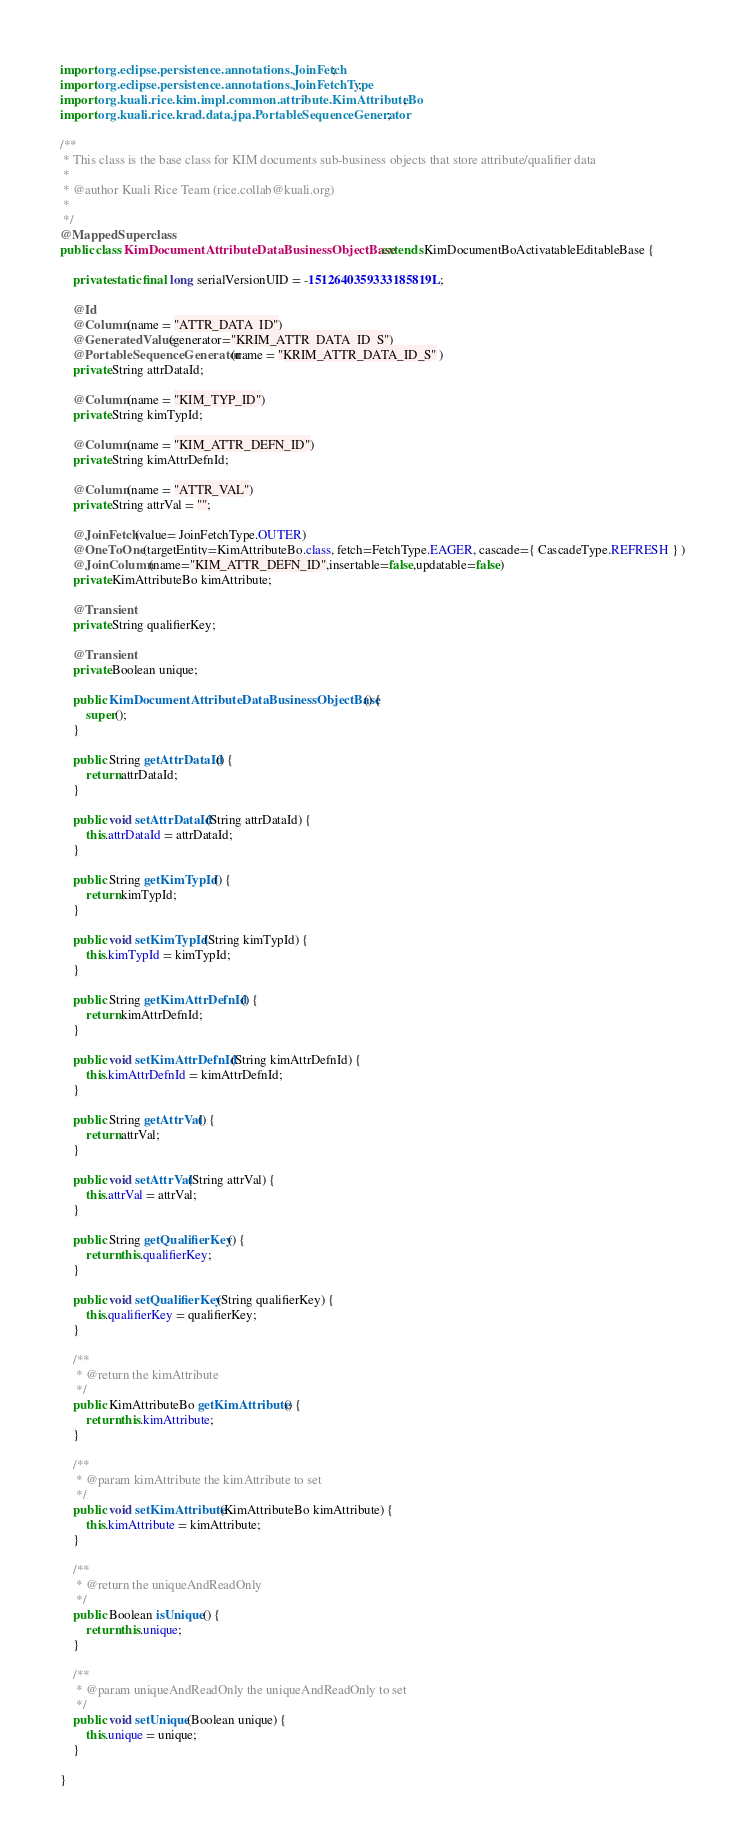<code> <loc_0><loc_0><loc_500><loc_500><_Java_>
import org.eclipse.persistence.annotations.JoinFetch;
import org.eclipse.persistence.annotations.JoinFetchType;
import org.kuali.rice.kim.impl.common.attribute.KimAttributeBo;
import org.kuali.rice.krad.data.jpa.PortableSequenceGenerator;

/**
 * This class is the base class for KIM documents sub-business objects that store attribute/qualifier data
 * 
 * @author Kuali Rice Team (rice.collab@kuali.org)
 *
 */
@MappedSuperclass
public class KimDocumentAttributeDataBusinessObjectBase extends KimDocumentBoActivatableEditableBase {

    private static final long serialVersionUID = -1512640359333185819L;

	@Id
	@Column(name = "ATTR_DATA_ID")
    @GeneratedValue(generator="KRIM_ATTR_DATA_ID_S")
    @PortableSequenceGenerator(name = "KRIM_ATTR_DATA_ID_S" )
	private String attrDataId;

	@Column(name = "KIM_TYP_ID")
	private String kimTypId;
	
	@Column(name = "KIM_ATTR_DEFN_ID")
	private String kimAttrDefnId;
	
	@Column(name = "ATTR_VAL")
	private String attrVal = "";

	@JoinFetch(value= JoinFetchType.OUTER)
	@OneToOne(targetEntity=KimAttributeBo.class, fetch=FetchType.EAGER, cascade={ CascadeType.REFRESH } )
    @JoinColumn(name="KIM_ATTR_DEFN_ID",insertable=false,updatable=false)
	private KimAttributeBo kimAttribute;
	
	@Transient
	private String qualifierKey;
	
	@Transient
	private Boolean unique;
	
	public KimDocumentAttributeDataBusinessObjectBase() {
		super();
	}

	public String getAttrDataId() {
		return attrDataId;
	}

	public void setAttrDataId(String attrDataId) {
		this.attrDataId = attrDataId;
	}

	public String getKimTypId() {
		return kimTypId;
	}

	public void setKimTypId(String kimTypId) {
		this.kimTypId = kimTypId;
	}

	public String getKimAttrDefnId() {
		return kimAttrDefnId;
	}

	public void setKimAttrDefnId(String kimAttrDefnId) {
		this.kimAttrDefnId = kimAttrDefnId;
	}

	public String getAttrVal() {
		return attrVal;
	}

	public void setAttrVal(String attrVal) {
		this.attrVal = attrVal;
	}

	public String getQualifierKey() {
		return this.qualifierKey;
	}

	public void setQualifierKey(String qualifierKey) {
		this.qualifierKey = qualifierKey;
	}

	/**
	 * @return the kimAttribute
	 */
	public KimAttributeBo getKimAttribute() {
		return this.kimAttribute;
	}

	/**
	 * @param kimAttribute the kimAttribute to set
	 */
	public void setKimAttribute(KimAttributeBo kimAttribute) {
		this.kimAttribute = kimAttribute;
	}

	/**
	 * @return the uniqueAndReadOnly
	 */
	public Boolean isUnique() {
		return this.unique;
	}

	/**
	 * @param uniqueAndReadOnly the uniqueAndReadOnly to set
	 */
	public void setUnique(Boolean unique) {
		this.unique = unique;
	}

}
</code> 